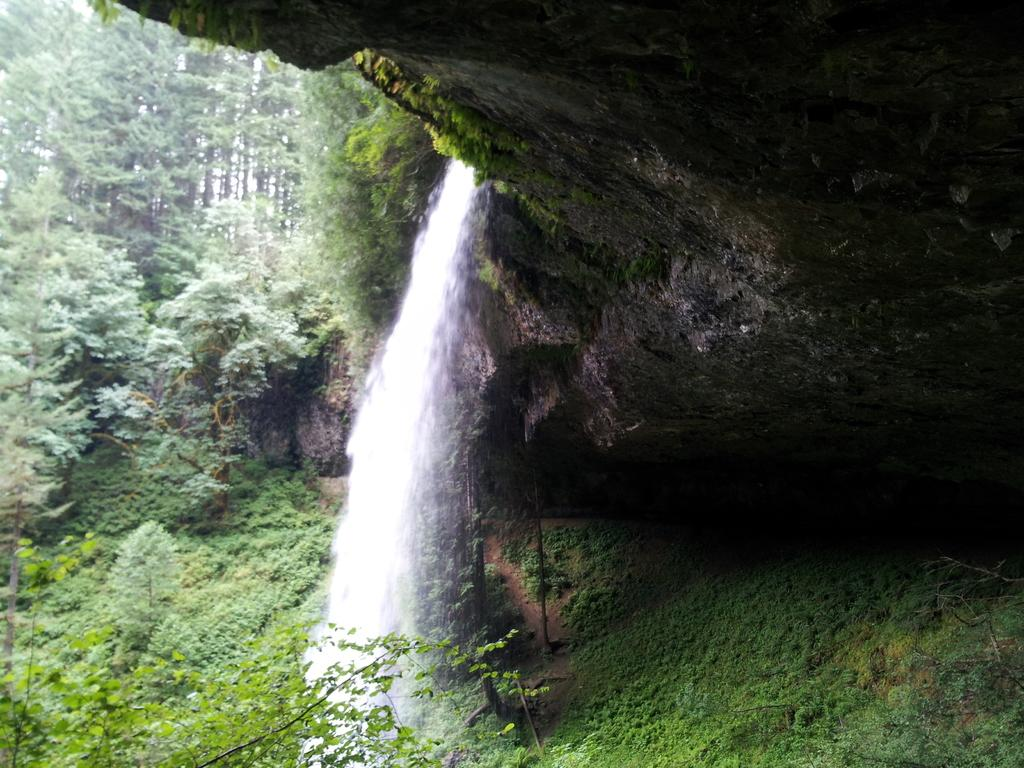What is visible in the image? Water is visible in the image. What is covering the ground in the image? The ground appears to be covered in greenery. What can be seen in the background of the image? There are trees in the background of the image. Where is the chalk located in the image? There is no chalk present in the image. What type of market can be seen in the image? There is no market present in the image. 